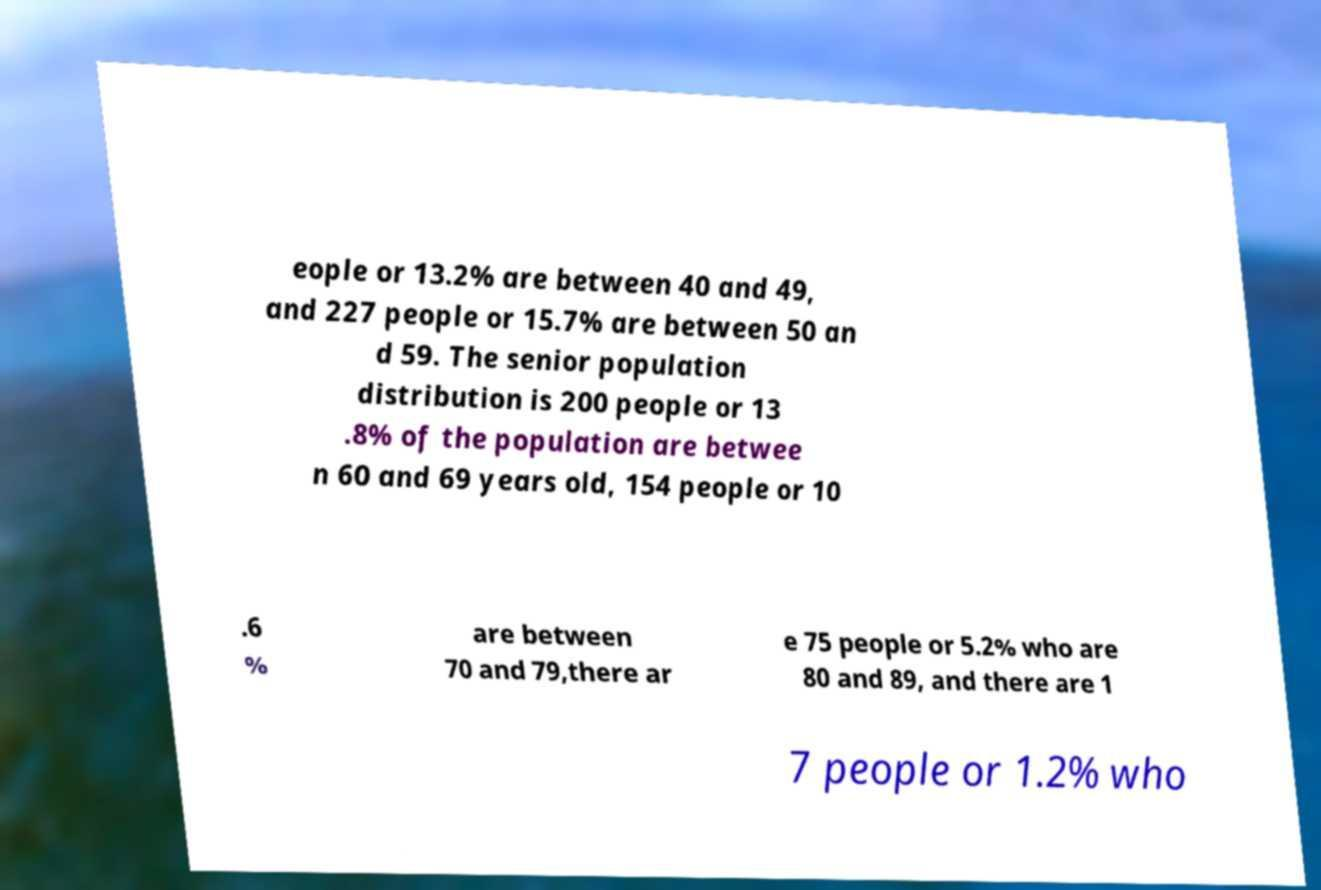What messages or text are displayed in this image? I need them in a readable, typed format. eople or 13.2% are between 40 and 49, and 227 people or 15.7% are between 50 an d 59. The senior population distribution is 200 people or 13 .8% of the population are betwee n 60 and 69 years old, 154 people or 10 .6 % are between 70 and 79,there ar e 75 people or 5.2% who are 80 and 89, and there are 1 7 people or 1.2% who 